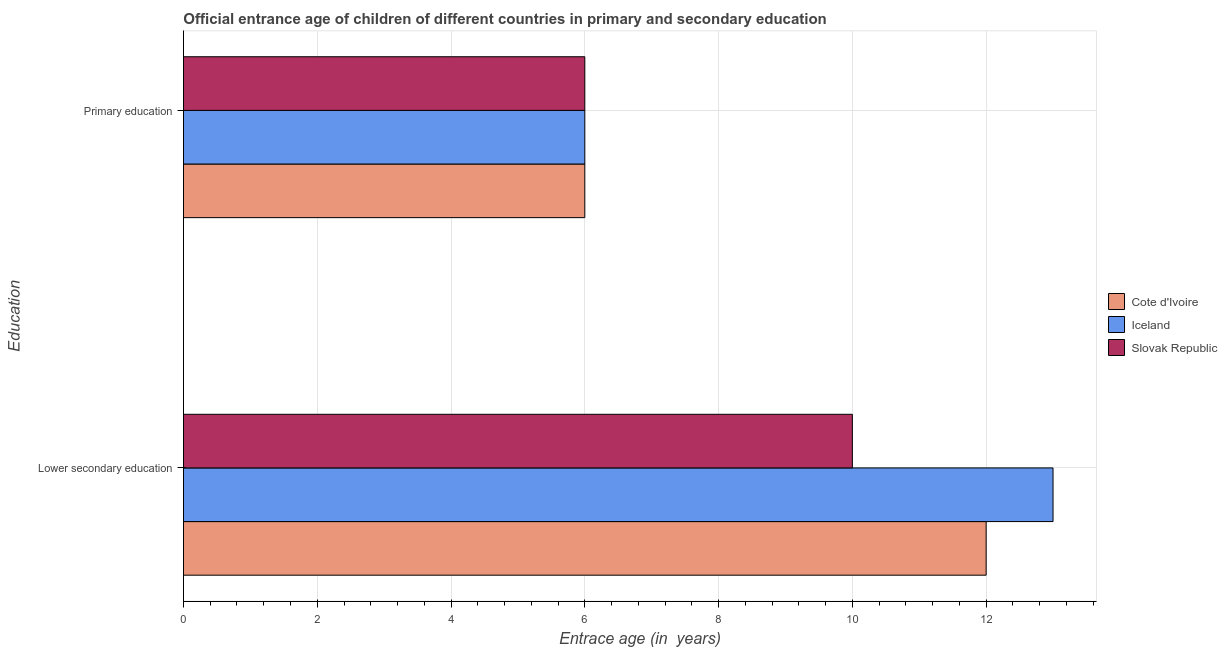How many different coloured bars are there?
Give a very brief answer. 3. How many groups of bars are there?
Your answer should be very brief. 2. Are the number of bars on each tick of the Y-axis equal?
Give a very brief answer. Yes. How many bars are there on the 2nd tick from the top?
Offer a terse response. 3. What is the label of the 2nd group of bars from the top?
Give a very brief answer. Lower secondary education. What is the entrance age of chiildren in primary education in Slovak Republic?
Offer a very short reply. 6. Across all countries, what is the minimum entrance age of children in lower secondary education?
Give a very brief answer. 10. In which country was the entrance age of chiildren in primary education maximum?
Your answer should be compact. Cote d'Ivoire. In which country was the entrance age of chiildren in primary education minimum?
Provide a short and direct response. Cote d'Ivoire. What is the total entrance age of children in lower secondary education in the graph?
Ensure brevity in your answer.  35. What is the difference between the entrance age of children in lower secondary education in Slovak Republic and that in Cote d'Ivoire?
Give a very brief answer. -2. What is the difference between the entrance age of chiildren in primary education in Slovak Republic and the entrance age of children in lower secondary education in Iceland?
Your response must be concise. -7. What is the average entrance age of children in lower secondary education per country?
Provide a succinct answer. 11.67. What is the difference between the entrance age of children in lower secondary education and entrance age of chiildren in primary education in Slovak Republic?
Your answer should be compact. 4. What is the ratio of the entrance age of children in lower secondary education in Cote d'Ivoire to that in Iceland?
Keep it short and to the point. 0.92. In how many countries, is the entrance age of chiildren in primary education greater than the average entrance age of chiildren in primary education taken over all countries?
Give a very brief answer. 0. What does the 3rd bar from the top in Lower secondary education represents?
Keep it short and to the point. Cote d'Ivoire. How many bars are there?
Provide a short and direct response. 6. How many countries are there in the graph?
Provide a succinct answer. 3. What is the difference between two consecutive major ticks on the X-axis?
Offer a very short reply. 2. What is the title of the graph?
Provide a short and direct response. Official entrance age of children of different countries in primary and secondary education. What is the label or title of the X-axis?
Offer a terse response. Entrace age (in  years). What is the label or title of the Y-axis?
Your response must be concise. Education. What is the Entrace age (in  years) of Cote d'Ivoire in Lower secondary education?
Offer a terse response. 12. What is the Entrace age (in  years) of Slovak Republic in Lower secondary education?
Provide a succinct answer. 10. What is the Entrace age (in  years) of Slovak Republic in Primary education?
Ensure brevity in your answer.  6. Across all Education, what is the maximum Entrace age (in  years) of Iceland?
Provide a succinct answer. 13. What is the total Entrace age (in  years) in Slovak Republic in the graph?
Provide a short and direct response. 16. What is the difference between the Entrace age (in  years) of Cote d'Ivoire in Lower secondary education and the Entrace age (in  years) of Iceland in Primary education?
Make the answer very short. 6. What is the difference between the Entrace age (in  years) in Iceland in Lower secondary education and the Entrace age (in  years) in Slovak Republic in Primary education?
Your response must be concise. 7. What is the average Entrace age (in  years) in Cote d'Ivoire per Education?
Give a very brief answer. 9. What is the average Entrace age (in  years) of Iceland per Education?
Provide a short and direct response. 9.5. What is the difference between the Entrace age (in  years) in Iceland and Entrace age (in  years) in Slovak Republic in Lower secondary education?
Provide a short and direct response. 3. What is the difference between the Entrace age (in  years) in Iceland and Entrace age (in  years) in Slovak Republic in Primary education?
Make the answer very short. 0. What is the ratio of the Entrace age (in  years) of Iceland in Lower secondary education to that in Primary education?
Give a very brief answer. 2.17. What is the ratio of the Entrace age (in  years) in Slovak Republic in Lower secondary education to that in Primary education?
Keep it short and to the point. 1.67. What is the difference between the highest and the second highest Entrace age (in  years) in Cote d'Ivoire?
Your answer should be compact. 6. 